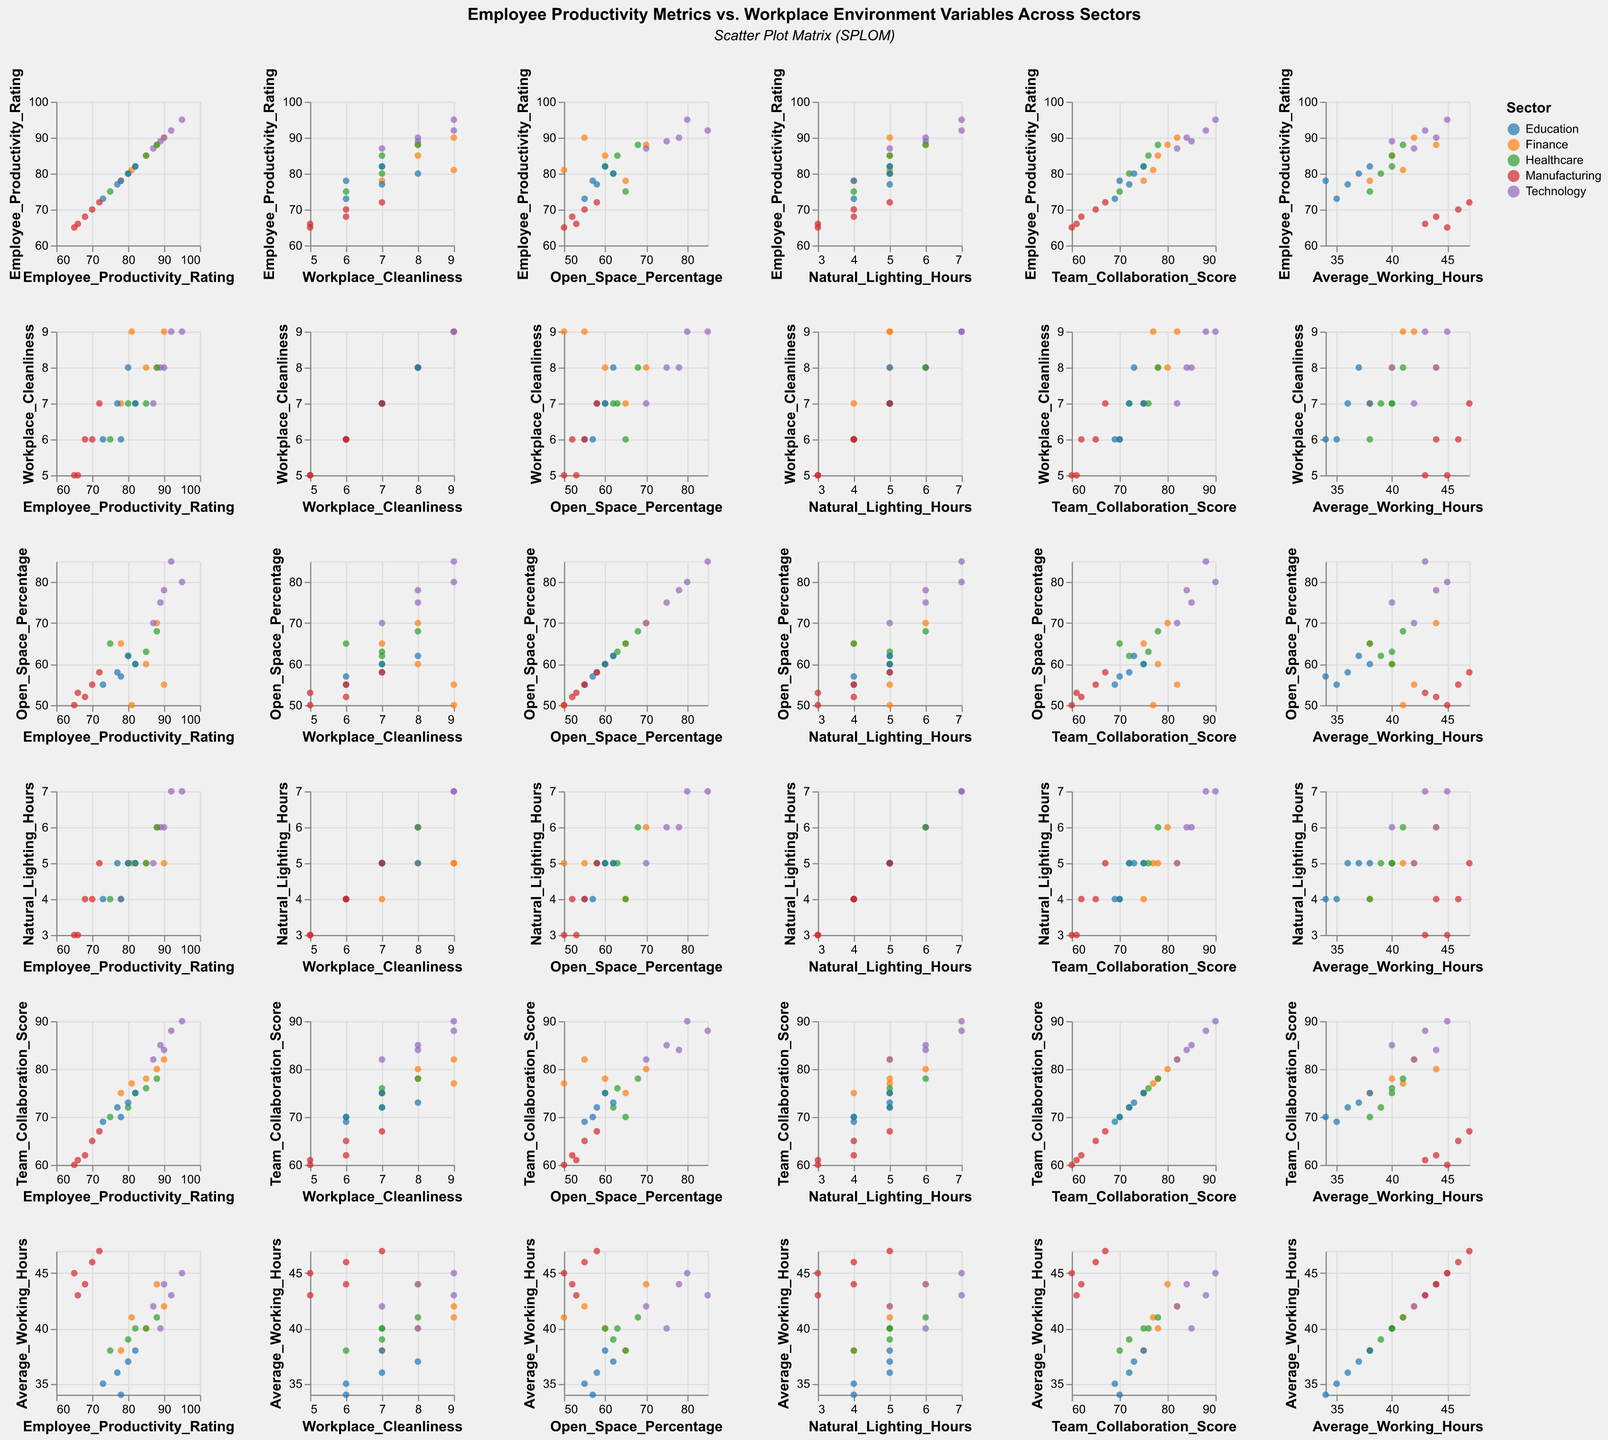What is the title of the figure? The title is usually displayed at the top of the figure and provides a brief description of what the figure represents.
Answer: Employee Productivity Metrics vs. Workplace Environment Variables Across Sectors Which sector has the highest Employee Productivity Rating in the Technology sector? To find this, look for the highest point in the Technology sector in the Employee Productivity Rating column.
Answer: Technology, with a rating of 95 What's the median Workplace Cleanliness score for the Finance sector? Order the Workplace Cleanliness scores for the Finance sector: 7, 8, 8, 8, 9. The median is the middle value.
Answer: 8 Is there a visible correlation between Natural Lighting Hours and Employee Productivity Rating across sectors? By examining the scatter plot matrix, observe the relationship between Natural Lighting Hours and Employee Productivity Rating across different sectors.
Answer: Yes, there is a positive correlation Which two sectors appear to have the closest average Team Collaboration Scores? Calculate the average Team Collaboration Scores for each sector and compare them. For simplicity, observe plotted points for each sector.
Answer: Finance and Education What is the range of Open Space Percentage in the Manufacturing sector? Identify the minimum and maximum Open Space Percentage in Manufacturing sector data and find the difference.
Answer: 8 (from 50 to 58) How does the average Working Hours in the Healthcare sector compare to the Technology sector? Find the average Working Hours for both sectors by summing the values and dividing by the number of data points in each sector.
Answer: Lower in Healthcare Which sector has the most data points in the figure? Visualize or count the number of data points in each sector's color and compare.
Answer: Finance Is there any outlier visible in the scatter plot matrix for Team Collaboration Score? Look for any data point for Team Collaboration Score that lies far from the others in the scatter plot matrix for each sector.
Answer: No clear outliers Does the Finance sector show any relationship between Workplace Cleanliness and Employee Productivity Rating? By examining the scatter plot matrix for Finance sector, look at the correlation between Workplace Cleanliness and Employee Productivity Rating.
Answer: Yes, a positive relationship 